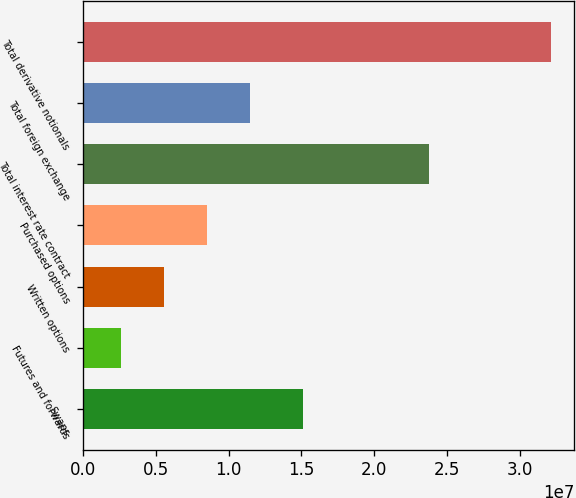Convert chart to OTSL. <chart><loc_0><loc_0><loc_500><loc_500><bar_chart><fcel>Swaps<fcel>Futures and forwards<fcel>Written options<fcel>Purchased options<fcel>Total interest rate contract<fcel>Total foreign exchange<fcel>Total derivative notionals<nl><fcel>1.50963e+07<fcel>2.61995e+06<fcel>5.56934e+06<fcel>8.51873e+06<fcel>2.3747e+07<fcel>1.14681e+07<fcel>3.21139e+07<nl></chart> 